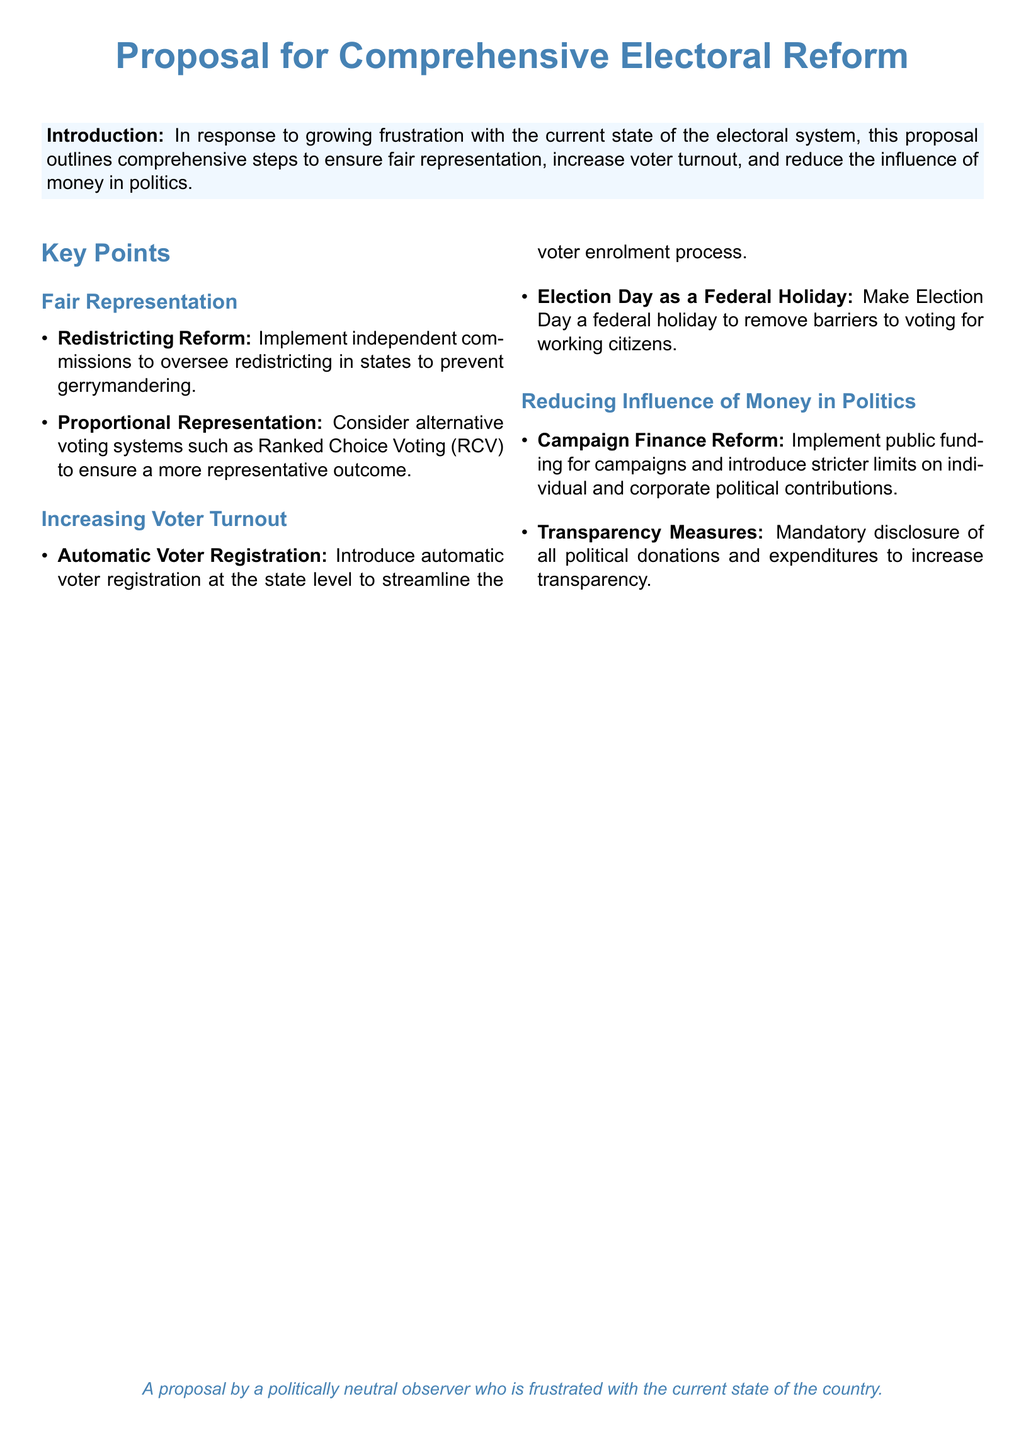What is the main focus of the proposal? The proposal focuses on revitalizing the electoral system and ensuring fair representation.
Answer: Revitalizing the electoral system What method is suggested to prevent gerrymandering? The proposal suggests implementing independent commissions to oversee redistricting.
Answer: Independent commissions What voting system is proposed to consider for fair representation? The proposal suggests considering alternative voting systems such as Ranked Choice Voting (RCV).
Answer: Ranked Choice Voting How is voter registration proposed to be streamlined? The proposal includes introducing automatic voter registration at the state level.
Answer: Automatic voter registration What measure is proposed to help increase voter turnout on Election Day? Making Election Day a federal holiday is proposed to help increase voter turnout.
Answer: Federal holiday What type of reform is suggested for campaign financing? The proposal suggests implementing public funding for campaigns as a reform.
Answer: Public funding What transparency measure is recommended in the proposal? The proposal recommends mandatory disclosure of all political donations and expenditures.
Answer: Mandatory disclosure Who is the proposal authored by? The proposal is authored by a politically neutral observer frustrated with the current state of the country.
Answer: Politically neutral observer 